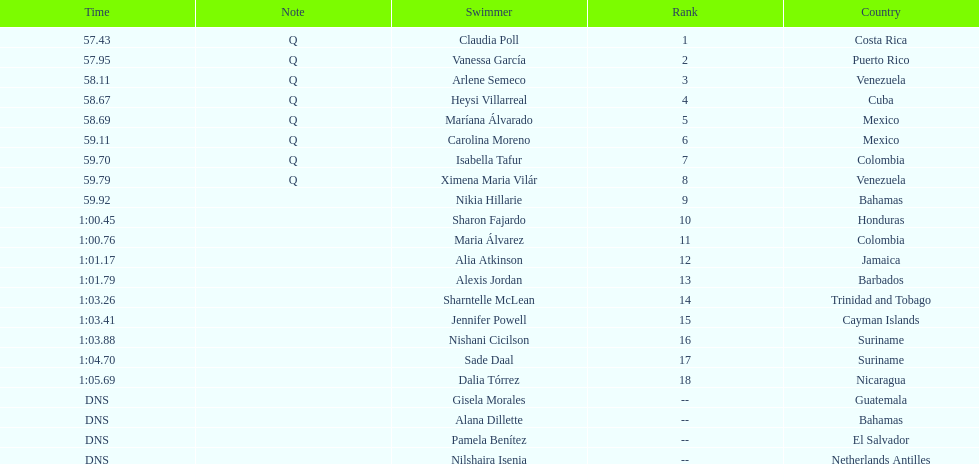How many competitors did not start the preliminaries? 4. 